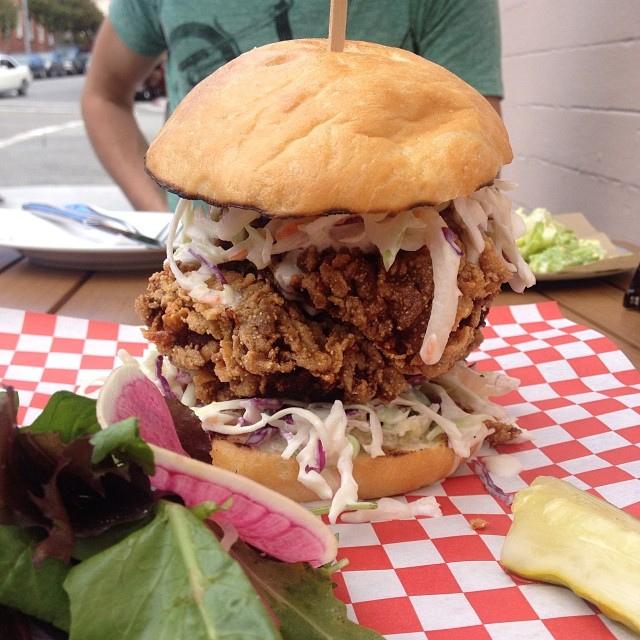Did the cook toast this bread?
Short answer required. Yes. Why is this sandwich so big?
Keep it brief. Contest. Is thus sandwich loaded?
Concise answer only. Yes. 